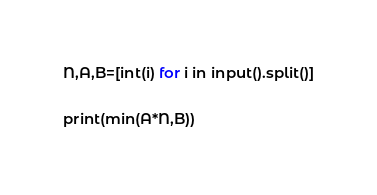Convert code to text. <code><loc_0><loc_0><loc_500><loc_500><_Python_>N,A,B=[int(i) for i in input().split()]

print(min(A*N,B))</code> 